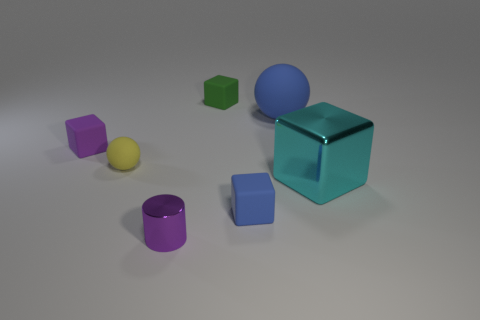Add 2 small purple shiny cylinders. How many objects exist? 9 Subtract all cubes. How many objects are left? 3 Add 6 big cyan cylinders. How many big cyan cylinders exist? 6 Subtract 0 gray cubes. How many objects are left? 7 Subtract all cyan metallic objects. Subtract all tiny purple cubes. How many objects are left? 5 Add 7 purple metal cylinders. How many purple metal cylinders are left? 8 